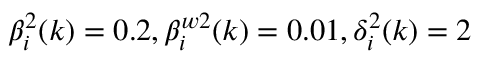<formula> <loc_0><loc_0><loc_500><loc_500>\beta _ { i } ^ { 2 } ( k ) = 0 . 2 , \beta _ { i } ^ { w 2 } ( k ) = 0 . 0 1 , \delta _ { i } ^ { 2 } ( k ) = 2</formula> 